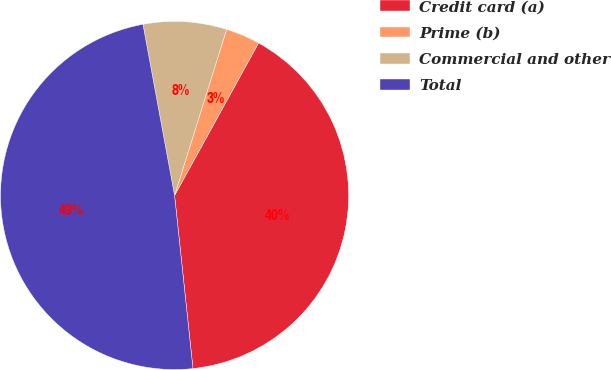Convert chart to OTSL. <chart><loc_0><loc_0><loc_500><loc_500><pie_chart><fcel>Credit card (a)<fcel>Prime (b)<fcel>Commercial and other<fcel>Total<nl><fcel>40.3%<fcel>3.18%<fcel>7.74%<fcel>48.78%<nl></chart> 